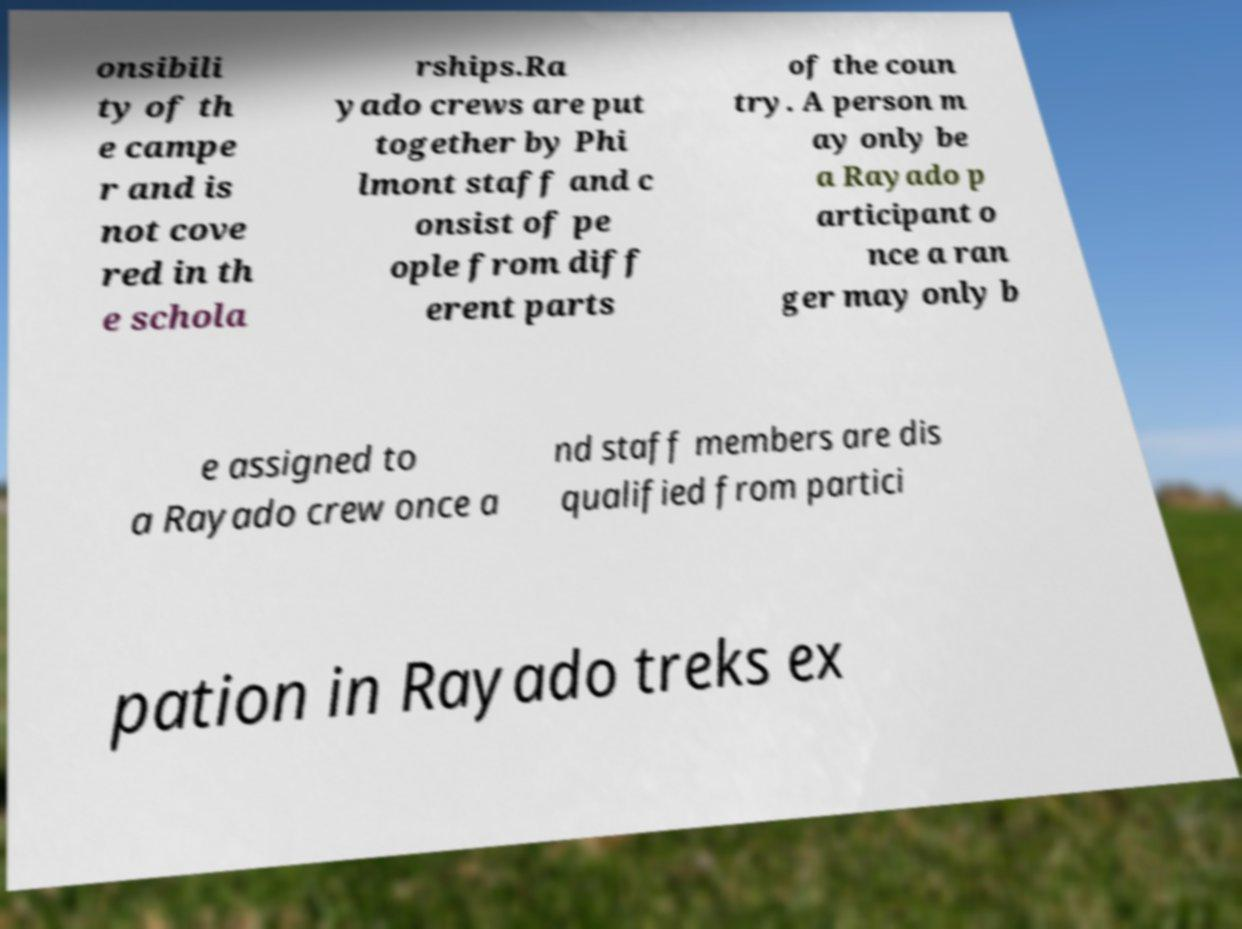What messages or text are displayed in this image? I need them in a readable, typed format. onsibili ty of th e campe r and is not cove red in th e schola rships.Ra yado crews are put together by Phi lmont staff and c onsist of pe ople from diff erent parts of the coun try. A person m ay only be a Rayado p articipant o nce a ran ger may only b e assigned to a Rayado crew once a nd staff members are dis qualified from partici pation in Rayado treks ex 